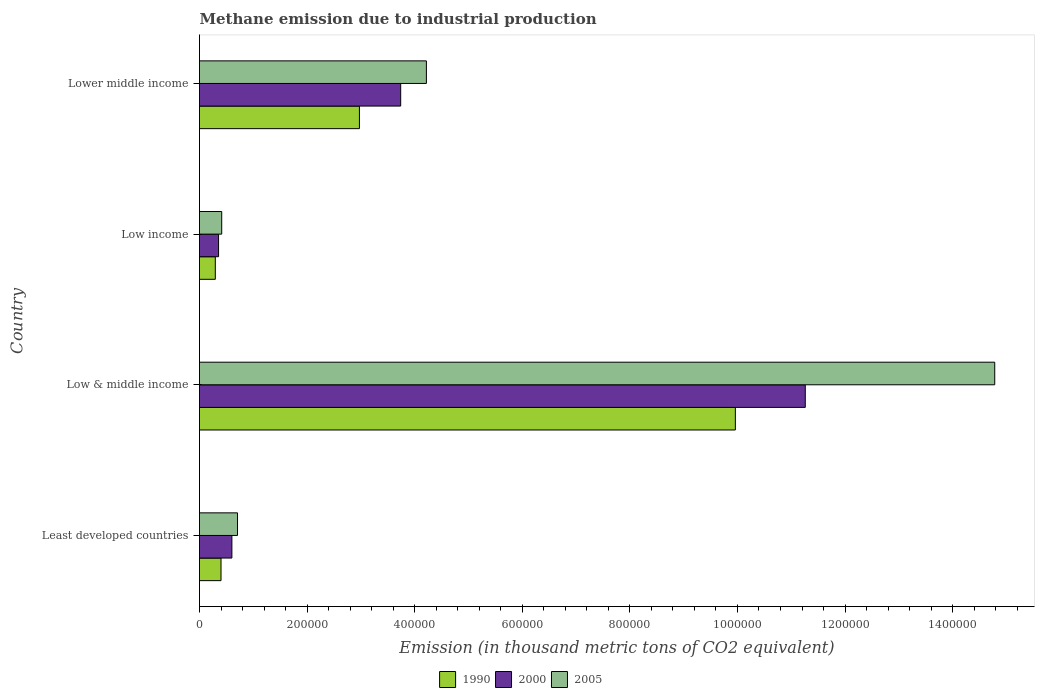How many different coloured bars are there?
Offer a terse response. 3. Are the number of bars per tick equal to the number of legend labels?
Your answer should be compact. Yes. In how many cases, is the number of bars for a given country not equal to the number of legend labels?
Offer a very short reply. 0. What is the amount of methane emitted in 2000 in Low income?
Provide a succinct answer. 3.54e+04. Across all countries, what is the maximum amount of methane emitted in 1990?
Offer a terse response. 9.96e+05. Across all countries, what is the minimum amount of methane emitted in 2005?
Keep it short and to the point. 4.13e+04. In which country was the amount of methane emitted in 2005 maximum?
Make the answer very short. Low & middle income. What is the total amount of methane emitted in 1990 in the graph?
Give a very brief answer. 1.36e+06. What is the difference between the amount of methane emitted in 1990 in Low & middle income and that in Lower middle income?
Your response must be concise. 6.99e+05. What is the difference between the amount of methane emitted in 1990 in Lower middle income and the amount of methane emitted in 2000 in Least developed countries?
Give a very brief answer. 2.37e+05. What is the average amount of methane emitted in 2000 per country?
Your answer should be compact. 3.99e+05. What is the difference between the amount of methane emitted in 1990 and amount of methane emitted in 2000 in Lower middle income?
Provide a succinct answer. -7.67e+04. What is the ratio of the amount of methane emitted in 2000 in Least developed countries to that in Lower middle income?
Offer a terse response. 0.16. What is the difference between the highest and the second highest amount of methane emitted in 2005?
Provide a short and direct response. 1.06e+06. What is the difference between the highest and the lowest amount of methane emitted in 2005?
Provide a short and direct response. 1.44e+06. In how many countries, is the amount of methane emitted in 1990 greater than the average amount of methane emitted in 1990 taken over all countries?
Ensure brevity in your answer.  1. What is the difference between two consecutive major ticks on the X-axis?
Keep it short and to the point. 2.00e+05. Are the values on the major ticks of X-axis written in scientific E-notation?
Your answer should be compact. No. Does the graph contain any zero values?
Offer a very short reply. No. Where does the legend appear in the graph?
Make the answer very short. Bottom center. How many legend labels are there?
Offer a terse response. 3. What is the title of the graph?
Provide a short and direct response. Methane emission due to industrial production. What is the label or title of the X-axis?
Offer a very short reply. Emission (in thousand metric tons of CO2 equivalent). What is the Emission (in thousand metric tons of CO2 equivalent) in 1990 in Least developed countries?
Offer a terse response. 4.00e+04. What is the Emission (in thousand metric tons of CO2 equivalent) in 2000 in Least developed countries?
Your answer should be very brief. 6.02e+04. What is the Emission (in thousand metric tons of CO2 equivalent) of 2005 in Least developed countries?
Your answer should be compact. 7.07e+04. What is the Emission (in thousand metric tons of CO2 equivalent) of 1990 in Low & middle income?
Give a very brief answer. 9.96e+05. What is the Emission (in thousand metric tons of CO2 equivalent) in 2000 in Low & middle income?
Offer a very short reply. 1.13e+06. What is the Emission (in thousand metric tons of CO2 equivalent) of 2005 in Low & middle income?
Provide a short and direct response. 1.48e+06. What is the Emission (in thousand metric tons of CO2 equivalent) in 1990 in Low income?
Give a very brief answer. 2.94e+04. What is the Emission (in thousand metric tons of CO2 equivalent) of 2000 in Low income?
Provide a succinct answer. 3.54e+04. What is the Emission (in thousand metric tons of CO2 equivalent) in 2005 in Low income?
Ensure brevity in your answer.  4.13e+04. What is the Emission (in thousand metric tons of CO2 equivalent) of 1990 in Lower middle income?
Keep it short and to the point. 2.97e+05. What is the Emission (in thousand metric tons of CO2 equivalent) of 2000 in Lower middle income?
Make the answer very short. 3.74e+05. What is the Emission (in thousand metric tons of CO2 equivalent) in 2005 in Lower middle income?
Your answer should be compact. 4.22e+05. Across all countries, what is the maximum Emission (in thousand metric tons of CO2 equivalent) in 1990?
Provide a succinct answer. 9.96e+05. Across all countries, what is the maximum Emission (in thousand metric tons of CO2 equivalent) in 2000?
Your answer should be very brief. 1.13e+06. Across all countries, what is the maximum Emission (in thousand metric tons of CO2 equivalent) in 2005?
Offer a terse response. 1.48e+06. Across all countries, what is the minimum Emission (in thousand metric tons of CO2 equivalent) in 1990?
Provide a succinct answer. 2.94e+04. Across all countries, what is the minimum Emission (in thousand metric tons of CO2 equivalent) in 2000?
Provide a succinct answer. 3.54e+04. Across all countries, what is the minimum Emission (in thousand metric tons of CO2 equivalent) in 2005?
Make the answer very short. 4.13e+04. What is the total Emission (in thousand metric tons of CO2 equivalent) in 1990 in the graph?
Give a very brief answer. 1.36e+06. What is the total Emission (in thousand metric tons of CO2 equivalent) in 2000 in the graph?
Keep it short and to the point. 1.60e+06. What is the total Emission (in thousand metric tons of CO2 equivalent) in 2005 in the graph?
Ensure brevity in your answer.  2.01e+06. What is the difference between the Emission (in thousand metric tons of CO2 equivalent) of 1990 in Least developed countries and that in Low & middle income?
Offer a very short reply. -9.56e+05. What is the difference between the Emission (in thousand metric tons of CO2 equivalent) in 2000 in Least developed countries and that in Low & middle income?
Provide a short and direct response. -1.07e+06. What is the difference between the Emission (in thousand metric tons of CO2 equivalent) in 2005 in Least developed countries and that in Low & middle income?
Ensure brevity in your answer.  -1.41e+06. What is the difference between the Emission (in thousand metric tons of CO2 equivalent) in 1990 in Least developed countries and that in Low income?
Your answer should be compact. 1.06e+04. What is the difference between the Emission (in thousand metric tons of CO2 equivalent) of 2000 in Least developed countries and that in Low income?
Your response must be concise. 2.48e+04. What is the difference between the Emission (in thousand metric tons of CO2 equivalent) of 2005 in Least developed countries and that in Low income?
Offer a very short reply. 2.94e+04. What is the difference between the Emission (in thousand metric tons of CO2 equivalent) in 1990 in Least developed countries and that in Lower middle income?
Offer a very short reply. -2.57e+05. What is the difference between the Emission (in thousand metric tons of CO2 equivalent) in 2000 in Least developed countries and that in Lower middle income?
Offer a very short reply. -3.14e+05. What is the difference between the Emission (in thousand metric tons of CO2 equivalent) in 2005 in Least developed countries and that in Lower middle income?
Provide a succinct answer. -3.51e+05. What is the difference between the Emission (in thousand metric tons of CO2 equivalent) in 1990 in Low & middle income and that in Low income?
Your response must be concise. 9.67e+05. What is the difference between the Emission (in thousand metric tons of CO2 equivalent) of 2000 in Low & middle income and that in Low income?
Your answer should be very brief. 1.09e+06. What is the difference between the Emission (in thousand metric tons of CO2 equivalent) of 2005 in Low & middle income and that in Low income?
Your response must be concise. 1.44e+06. What is the difference between the Emission (in thousand metric tons of CO2 equivalent) of 1990 in Low & middle income and that in Lower middle income?
Provide a short and direct response. 6.99e+05. What is the difference between the Emission (in thousand metric tons of CO2 equivalent) of 2000 in Low & middle income and that in Lower middle income?
Make the answer very short. 7.52e+05. What is the difference between the Emission (in thousand metric tons of CO2 equivalent) in 2005 in Low & middle income and that in Lower middle income?
Offer a very short reply. 1.06e+06. What is the difference between the Emission (in thousand metric tons of CO2 equivalent) in 1990 in Low income and that in Lower middle income?
Keep it short and to the point. -2.68e+05. What is the difference between the Emission (in thousand metric tons of CO2 equivalent) in 2000 in Low income and that in Lower middle income?
Provide a succinct answer. -3.39e+05. What is the difference between the Emission (in thousand metric tons of CO2 equivalent) in 2005 in Low income and that in Lower middle income?
Ensure brevity in your answer.  -3.80e+05. What is the difference between the Emission (in thousand metric tons of CO2 equivalent) of 1990 in Least developed countries and the Emission (in thousand metric tons of CO2 equivalent) of 2000 in Low & middle income?
Ensure brevity in your answer.  -1.09e+06. What is the difference between the Emission (in thousand metric tons of CO2 equivalent) of 1990 in Least developed countries and the Emission (in thousand metric tons of CO2 equivalent) of 2005 in Low & middle income?
Ensure brevity in your answer.  -1.44e+06. What is the difference between the Emission (in thousand metric tons of CO2 equivalent) in 2000 in Least developed countries and the Emission (in thousand metric tons of CO2 equivalent) in 2005 in Low & middle income?
Ensure brevity in your answer.  -1.42e+06. What is the difference between the Emission (in thousand metric tons of CO2 equivalent) in 1990 in Least developed countries and the Emission (in thousand metric tons of CO2 equivalent) in 2000 in Low income?
Give a very brief answer. 4550.8. What is the difference between the Emission (in thousand metric tons of CO2 equivalent) of 1990 in Least developed countries and the Emission (in thousand metric tons of CO2 equivalent) of 2005 in Low income?
Make the answer very short. -1306.5. What is the difference between the Emission (in thousand metric tons of CO2 equivalent) of 2000 in Least developed countries and the Emission (in thousand metric tons of CO2 equivalent) of 2005 in Low income?
Offer a very short reply. 1.89e+04. What is the difference between the Emission (in thousand metric tons of CO2 equivalent) in 1990 in Least developed countries and the Emission (in thousand metric tons of CO2 equivalent) in 2000 in Lower middle income?
Ensure brevity in your answer.  -3.34e+05. What is the difference between the Emission (in thousand metric tons of CO2 equivalent) of 1990 in Least developed countries and the Emission (in thousand metric tons of CO2 equivalent) of 2005 in Lower middle income?
Your response must be concise. -3.82e+05. What is the difference between the Emission (in thousand metric tons of CO2 equivalent) of 2000 in Least developed countries and the Emission (in thousand metric tons of CO2 equivalent) of 2005 in Lower middle income?
Provide a succinct answer. -3.62e+05. What is the difference between the Emission (in thousand metric tons of CO2 equivalent) in 1990 in Low & middle income and the Emission (in thousand metric tons of CO2 equivalent) in 2000 in Low income?
Ensure brevity in your answer.  9.61e+05. What is the difference between the Emission (in thousand metric tons of CO2 equivalent) in 1990 in Low & middle income and the Emission (in thousand metric tons of CO2 equivalent) in 2005 in Low income?
Your answer should be very brief. 9.55e+05. What is the difference between the Emission (in thousand metric tons of CO2 equivalent) of 2000 in Low & middle income and the Emission (in thousand metric tons of CO2 equivalent) of 2005 in Low income?
Offer a very short reply. 1.08e+06. What is the difference between the Emission (in thousand metric tons of CO2 equivalent) of 1990 in Low & middle income and the Emission (in thousand metric tons of CO2 equivalent) of 2000 in Lower middle income?
Your answer should be very brief. 6.22e+05. What is the difference between the Emission (in thousand metric tons of CO2 equivalent) in 1990 in Low & middle income and the Emission (in thousand metric tons of CO2 equivalent) in 2005 in Lower middle income?
Provide a short and direct response. 5.74e+05. What is the difference between the Emission (in thousand metric tons of CO2 equivalent) in 2000 in Low & middle income and the Emission (in thousand metric tons of CO2 equivalent) in 2005 in Lower middle income?
Keep it short and to the point. 7.04e+05. What is the difference between the Emission (in thousand metric tons of CO2 equivalent) in 1990 in Low income and the Emission (in thousand metric tons of CO2 equivalent) in 2000 in Lower middle income?
Make the answer very short. -3.45e+05. What is the difference between the Emission (in thousand metric tons of CO2 equivalent) in 1990 in Low income and the Emission (in thousand metric tons of CO2 equivalent) in 2005 in Lower middle income?
Provide a succinct answer. -3.92e+05. What is the difference between the Emission (in thousand metric tons of CO2 equivalent) in 2000 in Low income and the Emission (in thousand metric tons of CO2 equivalent) in 2005 in Lower middle income?
Provide a succinct answer. -3.86e+05. What is the average Emission (in thousand metric tons of CO2 equivalent) of 1990 per country?
Your answer should be compact. 3.41e+05. What is the average Emission (in thousand metric tons of CO2 equivalent) in 2000 per country?
Offer a very short reply. 3.99e+05. What is the average Emission (in thousand metric tons of CO2 equivalent) in 2005 per country?
Offer a very short reply. 5.03e+05. What is the difference between the Emission (in thousand metric tons of CO2 equivalent) in 1990 and Emission (in thousand metric tons of CO2 equivalent) in 2000 in Least developed countries?
Your response must be concise. -2.02e+04. What is the difference between the Emission (in thousand metric tons of CO2 equivalent) in 1990 and Emission (in thousand metric tons of CO2 equivalent) in 2005 in Least developed countries?
Your answer should be compact. -3.07e+04. What is the difference between the Emission (in thousand metric tons of CO2 equivalent) in 2000 and Emission (in thousand metric tons of CO2 equivalent) in 2005 in Least developed countries?
Provide a short and direct response. -1.05e+04. What is the difference between the Emission (in thousand metric tons of CO2 equivalent) in 1990 and Emission (in thousand metric tons of CO2 equivalent) in 2000 in Low & middle income?
Give a very brief answer. -1.30e+05. What is the difference between the Emission (in thousand metric tons of CO2 equivalent) in 1990 and Emission (in thousand metric tons of CO2 equivalent) in 2005 in Low & middle income?
Offer a terse response. -4.82e+05. What is the difference between the Emission (in thousand metric tons of CO2 equivalent) of 2000 and Emission (in thousand metric tons of CO2 equivalent) of 2005 in Low & middle income?
Give a very brief answer. -3.52e+05. What is the difference between the Emission (in thousand metric tons of CO2 equivalent) in 1990 and Emission (in thousand metric tons of CO2 equivalent) in 2000 in Low income?
Keep it short and to the point. -6052.7. What is the difference between the Emission (in thousand metric tons of CO2 equivalent) of 1990 and Emission (in thousand metric tons of CO2 equivalent) of 2005 in Low income?
Provide a succinct answer. -1.19e+04. What is the difference between the Emission (in thousand metric tons of CO2 equivalent) of 2000 and Emission (in thousand metric tons of CO2 equivalent) of 2005 in Low income?
Keep it short and to the point. -5857.3. What is the difference between the Emission (in thousand metric tons of CO2 equivalent) in 1990 and Emission (in thousand metric tons of CO2 equivalent) in 2000 in Lower middle income?
Ensure brevity in your answer.  -7.67e+04. What is the difference between the Emission (in thousand metric tons of CO2 equivalent) of 1990 and Emission (in thousand metric tons of CO2 equivalent) of 2005 in Lower middle income?
Offer a very short reply. -1.24e+05. What is the difference between the Emission (in thousand metric tons of CO2 equivalent) of 2000 and Emission (in thousand metric tons of CO2 equivalent) of 2005 in Lower middle income?
Make the answer very short. -4.78e+04. What is the ratio of the Emission (in thousand metric tons of CO2 equivalent) in 1990 in Least developed countries to that in Low & middle income?
Ensure brevity in your answer.  0.04. What is the ratio of the Emission (in thousand metric tons of CO2 equivalent) in 2000 in Least developed countries to that in Low & middle income?
Offer a terse response. 0.05. What is the ratio of the Emission (in thousand metric tons of CO2 equivalent) in 2005 in Least developed countries to that in Low & middle income?
Your answer should be compact. 0.05. What is the ratio of the Emission (in thousand metric tons of CO2 equivalent) in 1990 in Least developed countries to that in Low income?
Your answer should be very brief. 1.36. What is the ratio of the Emission (in thousand metric tons of CO2 equivalent) of 2000 in Least developed countries to that in Low income?
Provide a succinct answer. 1.7. What is the ratio of the Emission (in thousand metric tons of CO2 equivalent) of 2005 in Least developed countries to that in Low income?
Your answer should be compact. 1.71. What is the ratio of the Emission (in thousand metric tons of CO2 equivalent) in 1990 in Least developed countries to that in Lower middle income?
Offer a terse response. 0.13. What is the ratio of the Emission (in thousand metric tons of CO2 equivalent) of 2000 in Least developed countries to that in Lower middle income?
Offer a very short reply. 0.16. What is the ratio of the Emission (in thousand metric tons of CO2 equivalent) of 2005 in Least developed countries to that in Lower middle income?
Your answer should be compact. 0.17. What is the ratio of the Emission (in thousand metric tons of CO2 equivalent) in 1990 in Low & middle income to that in Low income?
Provide a short and direct response. 33.92. What is the ratio of the Emission (in thousand metric tons of CO2 equivalent) of 2000 in Low & middle income to that in Low income?
Your answer should be very brief. 31.79. What is the ratio of the Emission (in thousand metric tons of CO2 equivalent) in 2005 in Low & middle income to that in Low income?
Provide a short and direct response. 35.81. What is the ratio of the Emission (in thousand metric tons of CO2 equivalent) in 1990 in Low & middle income to that in Lower middle income?
Ensure brevity in your answer.  3.35. What is the ratio of the Emission (in thousand metric tons of CO2 equivalent) in 2000 in Low & middle income to that in Lower middle income?
Offer a terse response. 3.01. What is the ratio of the Emission (in thousand metric tons of CO2 equivalent) of 2005 in Low & middle income to that in Lower middle income?
Your answer should be compact. 3.51. What is the ratio of the Emission (in thousand metric tons of CO2 equivalent) of 1990 in Low income to that in Lower middle income?
Make the answer very short. 0.1. What is the ratio of the Emission (in thousand metric tons of CO2 equivalent) of 2000 in Low income to that in Lower middle income?
Make the answer very short. 0.09. What is the ratio of the Emission (in thousand metric tons of CO2 equivalent) in 2005 in Low income to that in Lower middle income?
Offer a terse response. 0.1. What is the difference between the highest and the second highest Emission (in thousand metric tons of CO2 equivalent) in 1990?
Provide a short and direct response. 6.99e+05. What is the difference between the highest and the second highest Emission (in thousand metric tons of CO2 equivalent) in 2000?
Your answer should be compact. 7.52e+05. What is the difference between the highest and the second highest Emission (in thousand metric tons of CO2 equivalent) of 2005?
Ensure brevity in your answer.  1.06e+06. What is the difference between the highest and the lowest Emission (in thousand metric tons of CO2 equivalent) in 1990?
Offer a terse response. 9.67e+05. What is the difference between the highest and the lowest Emission (in thousand metric tons of CO2 equivalent) in 2000?
Provide a succinct answer. 1.09e+06. What is the difference between the highest and the lowest Emission (in thousand metric tons of CO2 equivalent) in 2005?
Your response must be concise. 1.44e+06. 